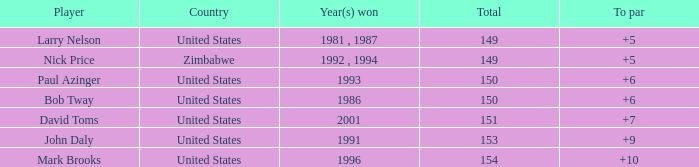Could you parse the entire table? {'header': ['Player', 'Country', 'Year(s) won', 'Total', 'To par'], 'rows': [['Larry Nelson', 'United States', '1981 , 1987', '149', '+5'], ['Nick Price', 'Zimbabwe', '1992 , 1994', '149', '+5'], ['Paul Azinger', 'United States', '1993', '150', '+6'], ['Bob Tway', 'United States', '1986', '150', '+6'], ['David Toms', 'United States', '2001', '151', '+7'], ['John Daly', 'United States', '1991', '153', '+9'], ['Mark Brooks', 'United States', '1996', '154', '+10']]} What is the sum for 1986 with a to par exceeding 6? 0.0. 